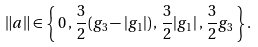<formula> <loc_0><loc_0><loc_500><loc_500>\| a \| \in \left \{ \, 0 \, , \, \frac { 3 } { 2 } ( g _ { 3 } - | g _ { 1 } | ) \, , \, \frac { 3 } { 2 } | g _ { 1 } | \, , \, \frac { 3 } { 2 } g _ { 3 } \, \right \} .</formula> 